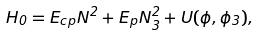<formula> <loc_0><loc_0><loc_500><loc_500>H _ { 0 } = E _ { c p } N ^ { 2 } + E _ { p } N _ { 3 } ^ { 2 } + U ( \phi , \phi _ { 3 } ) ,</formula> 